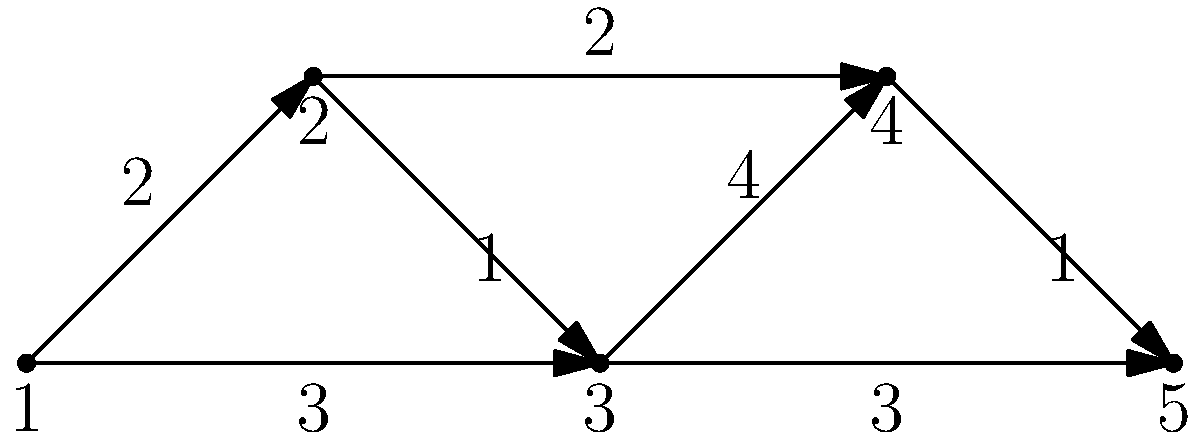You're planning your weekend voting route. The network graph represents different polling stations and the time (in minutes) to travel between them. What's the shortest path from station 1 to station 5, and how long will it take? Let's analyze this step-by-step:

1. We need to find the shortest path from node 1 to node 5.
2. Possible paths:
   a) 1 → 2 → 3 → 5
   b) 1 → 2 → 4 → 5
   c) 1 → 3 → 4 → 5
   d) 1 → 3 → 5

3. Let's calculate the total time for each path:
   a) 1 → 2 → 3 → 5 = 2 + 1 + 3 = 6 minutes
   b) 1 → 2 → 4 → 5 = 2 + 2 + 1 = 5 minutes
   c) 1 → 3 → 4 → 5 = 3 + 4 + 1 = 8 minutes
   d) 1 → 3 → 5 = 3 + 3 = 6 minutes

4. The shortest path is 1 → 2 → 4 → 5, taking 5 minutes.
Answer: 1 → 2 → 4 → 5, 5 minutes 